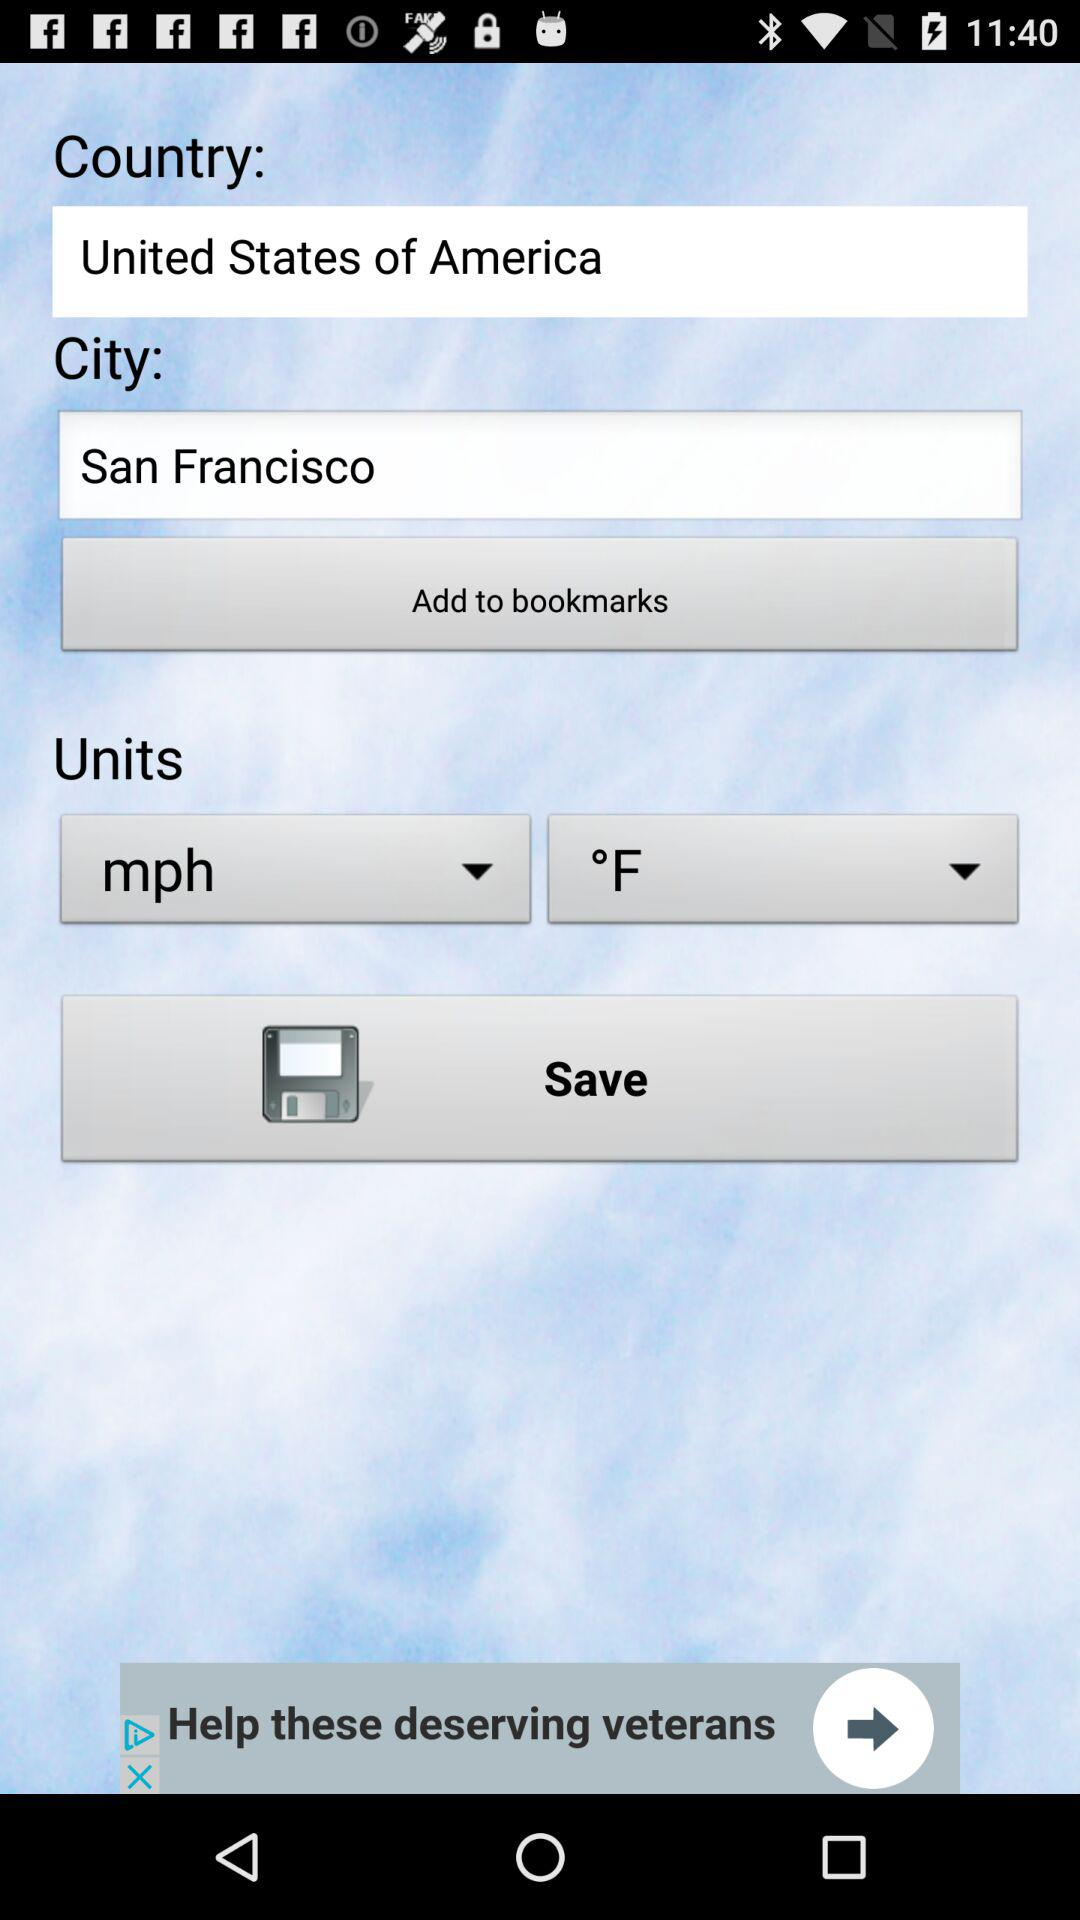Which city has been selected? The selected city is San Francisco. 